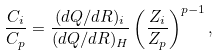Convert formula to latex. <formula><loc_0><loc_0><loc_500><loc_500>\frac { C _ { i } } { C _ { p } } = \frac { ( d Q / d R ) _ { i } } { ( d Q / d R ) _ { H } } \left ( \frac { Z _ { i } } { Z _ { p } } \right ) ^ { p - 1 } ,</formula> 